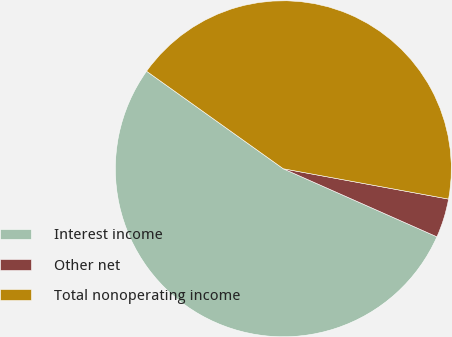Convert chart to OTSL. <chart><loc_0><loc_0><loc_500><loc_500><pie_chart><fcel>Interest income<fcel>Other net<fcel>Total nonoperating income<nl><fcel>53.23%<fcel>3.75%<fcel>43.03%<nl></chart> 